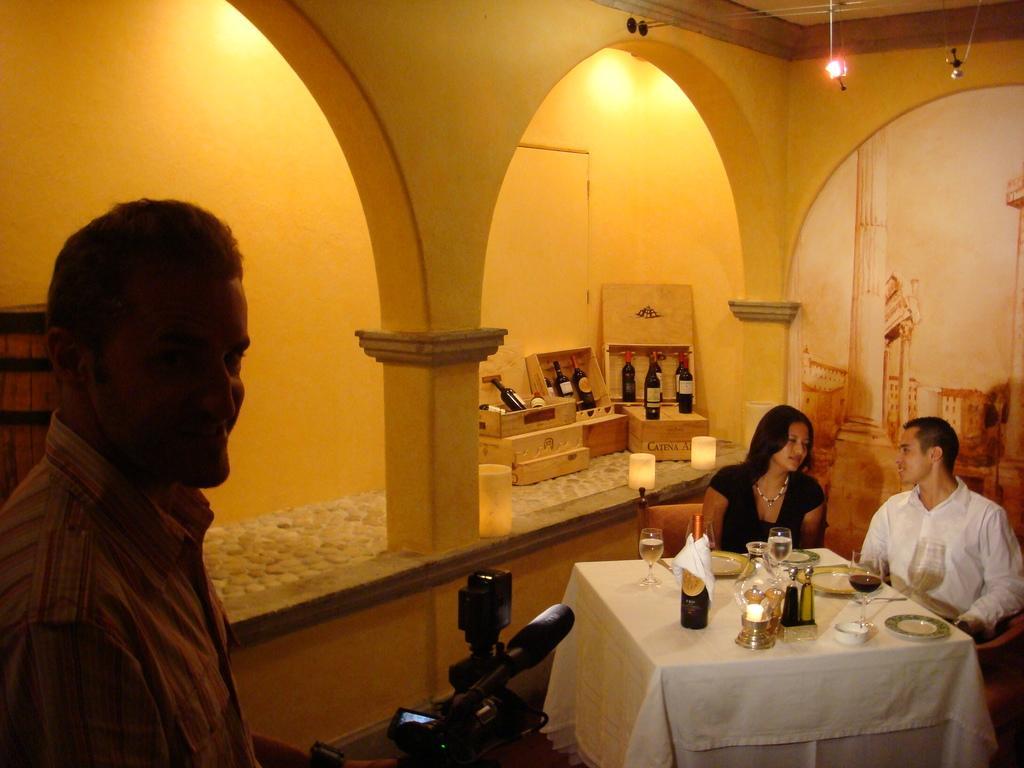Can you describe this image briefly? In this picture there is a man and a woman is sitting on the chair. There is a bottle,a glass and a plate on the table. To the left , there is a man who is holding a camera. At the background, there are few bottles in a box. There is a painting on the wall. There is a bulb hanged to the rod. 